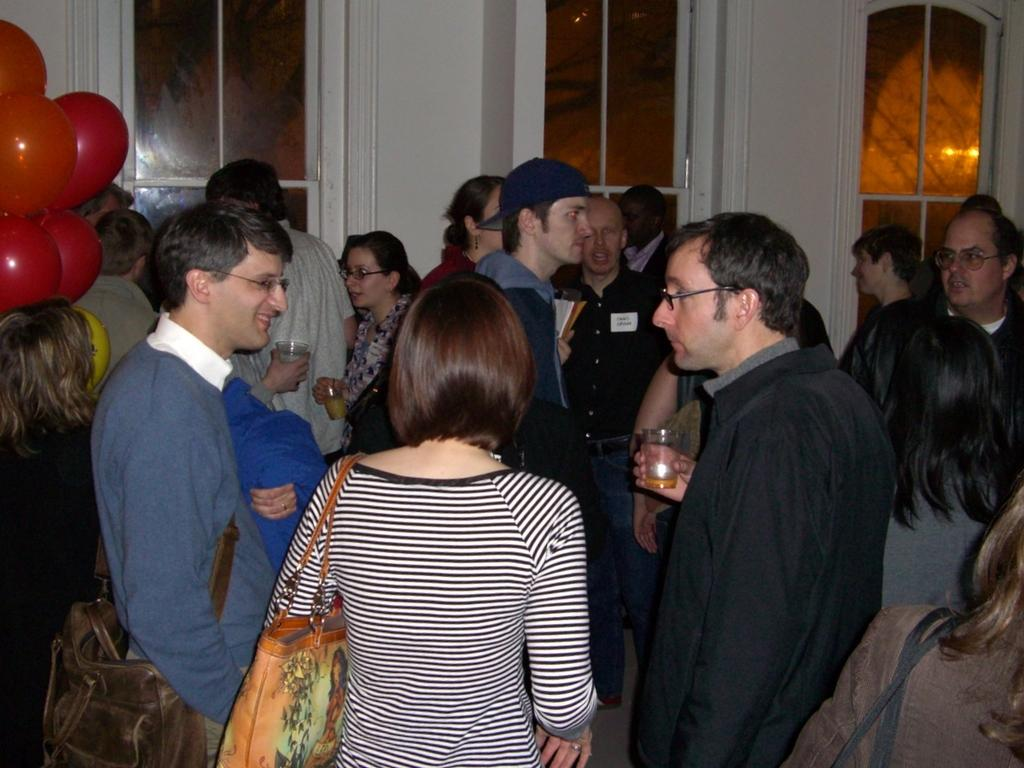What is happening in the image? There are people standing in the image. Where are the balloons located in the image? The balloons are on the left side of the image. What can be seen in the background of the image? There is a white color wall and windows visible in the background of the image. What type of help can be seen being provided in the image? There is no indication of help being provided in the image; it simply shows people standing and balloons on the left side. 